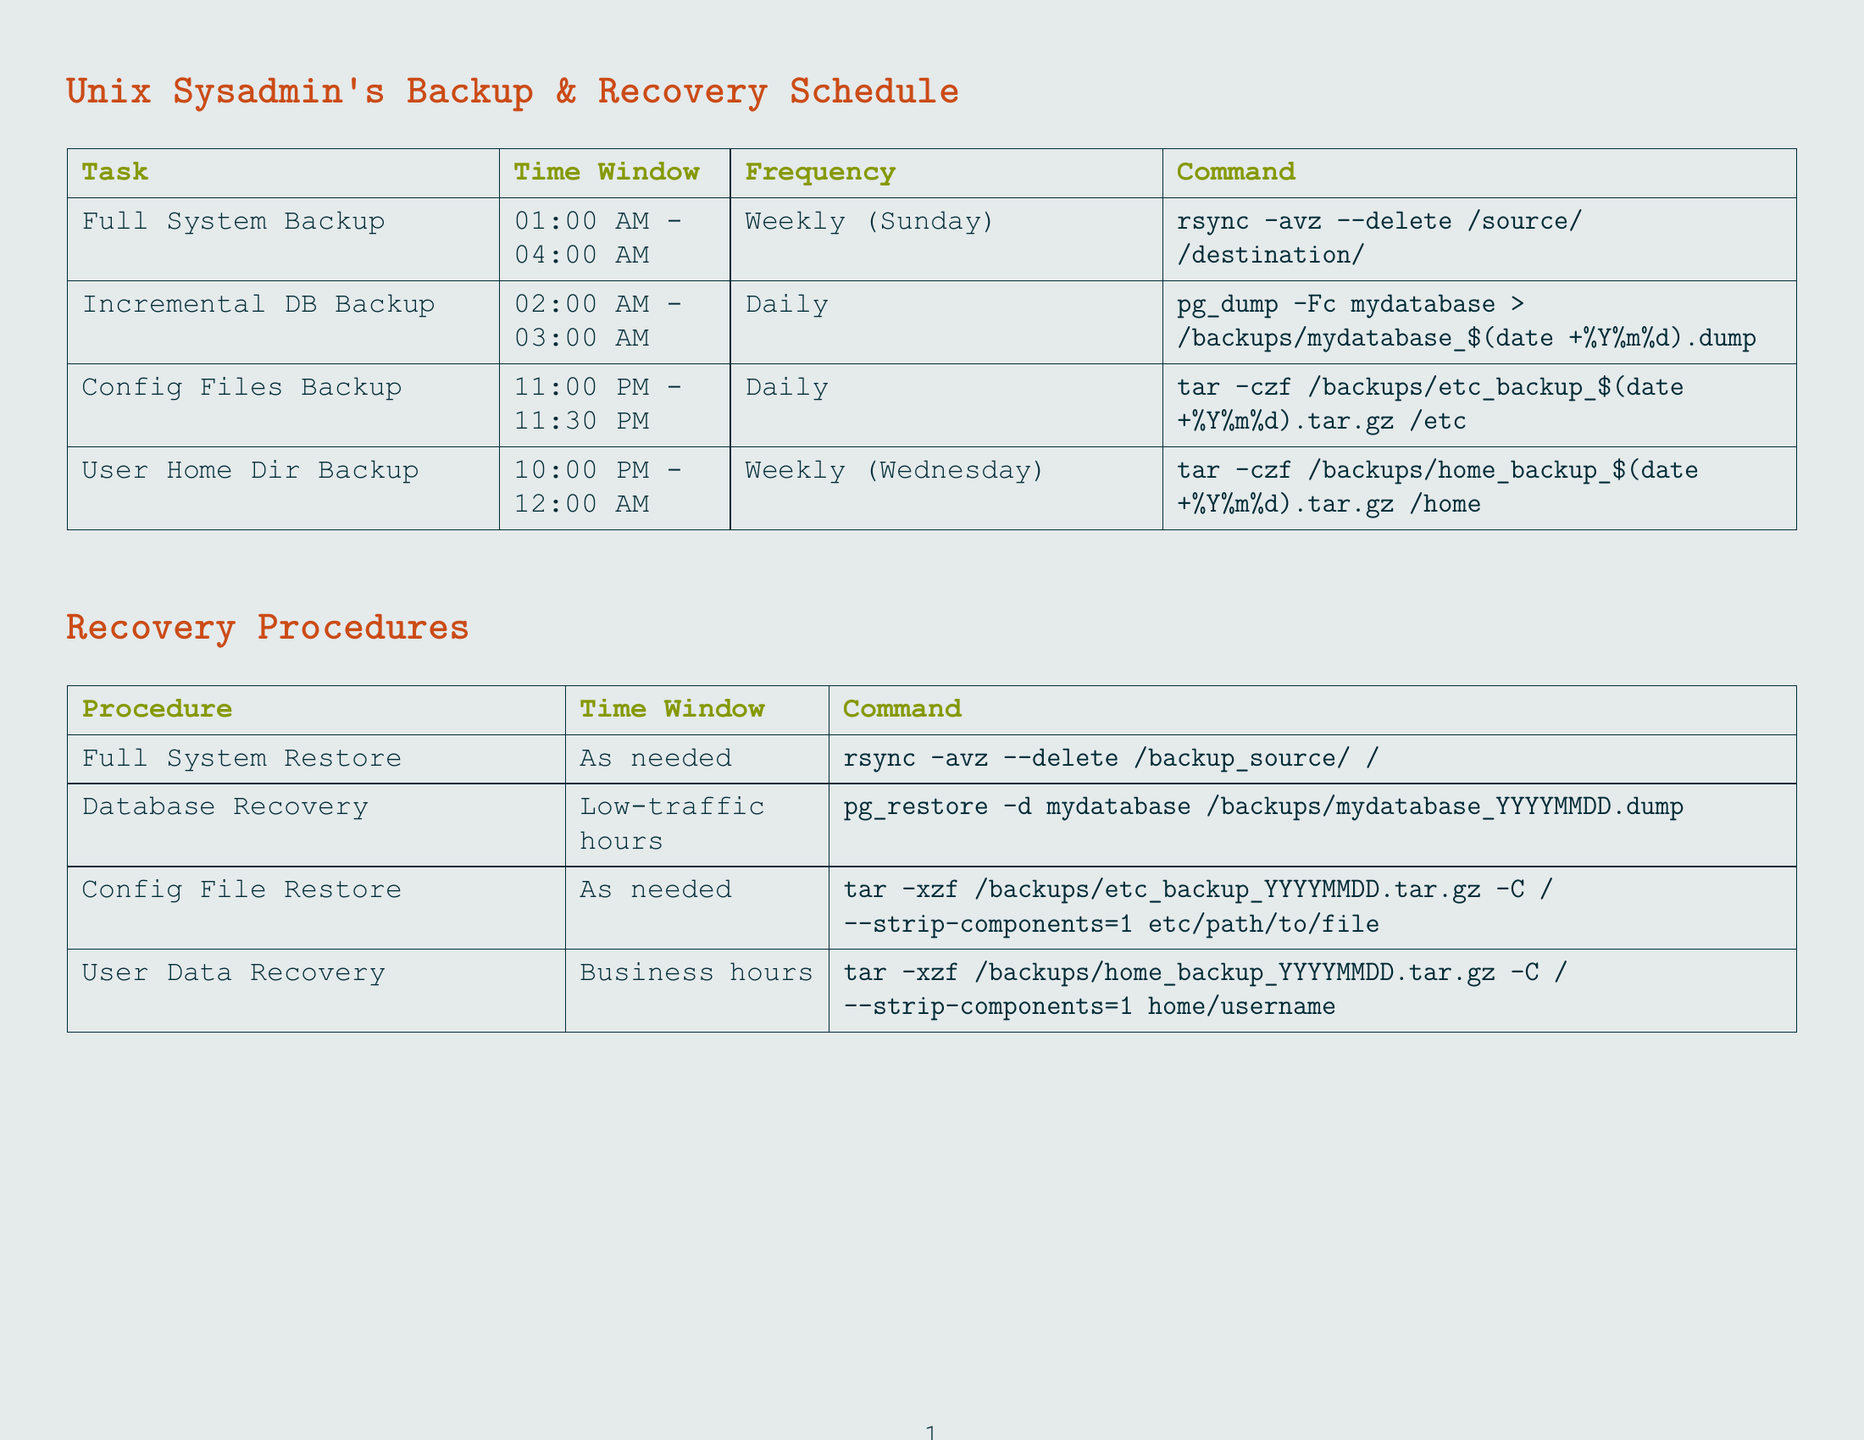what is the time window for the Full System Backup? The time window is specified in the document under the Full System Backup task.
Answer: 01:00 AM - 04:00 AM how often is the Incremental Database Backup performed? The frequency of this backup is stated in the document under its task description.
Answer: Daily what command is used for Configuration Files Backup? The document provides the command to perform this task in the respective section.
Answer: tar -czf /backups/etc_backup_$(date +%Y%m%d).tar.gz /etc when is the Backup Job Status Check scheduled? This question pertains to the scheduled time as listed in the monitoring tasks section of the document.
Answer: 08:00 AM - 09:00 AM what is the recovery time window for User Data Recovery? The recovery time window is detailed in the recovery procedures section.
Answer: During business hours which backup task has the longest time window? This question requires comparing the time windows of all backup tasks to find the one that lasts the longest.
Answer: User Home Directories Backup what are the prerequisites for Database Recovery? This question asks for the needed preparations to perform the recovery as listed in the document.
Answer: Stop the database service, Create an empty database if necessary what is one additional consideration mentioned in the document? One of the additional considerations is provided as a bullet point in the last section of the document.
Answer: Implement rotation policy for backups to manage storage efficiently how many monitoring tasks are listed in the schedule? This question requires counting the number of tasks in the monitoring section of the document.
Answer: 3 